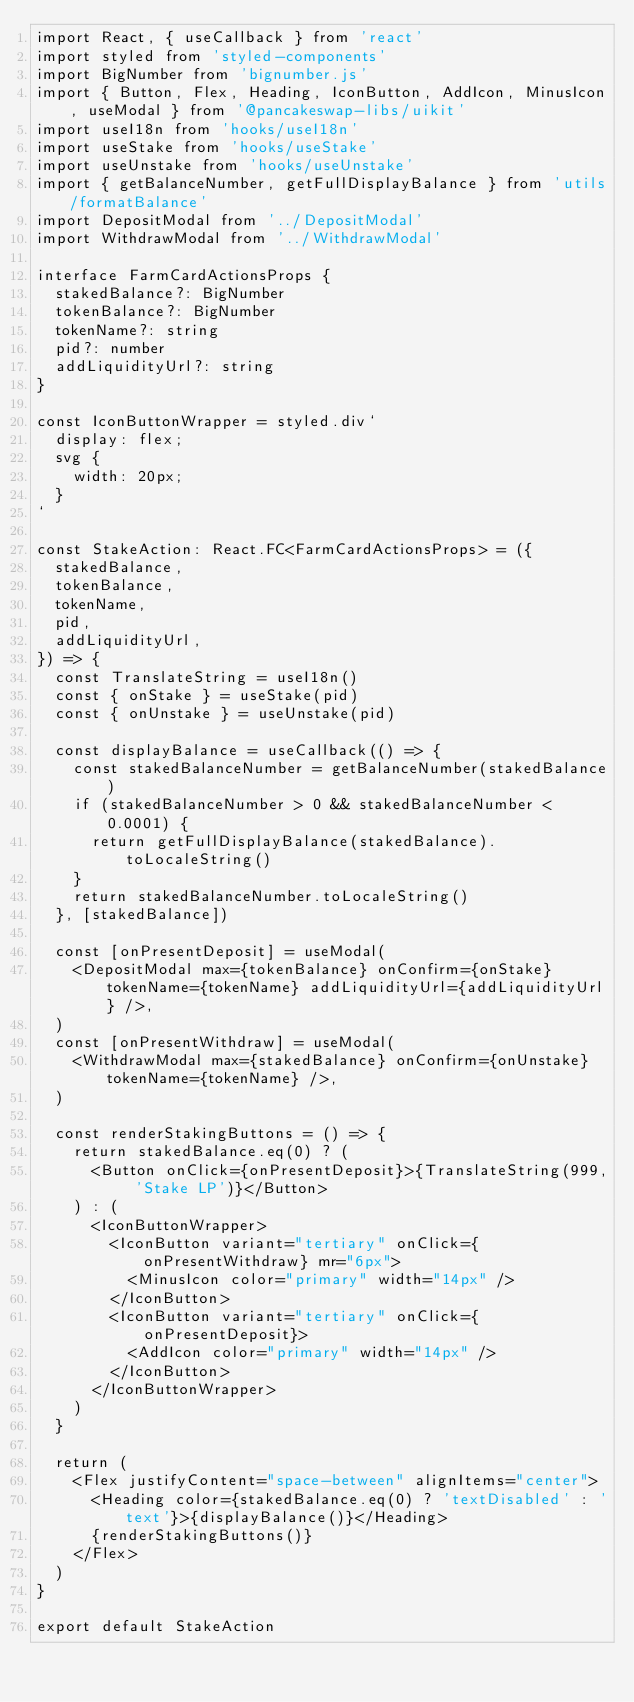<code> <loc_0><loc_0><loc_500><loc_500><_TypeScript_>import React, { useCallback } from 'react'
import styled from 'styled-components'
import BigNumber from 'bignumber.js'
import { Button, Flex, Heading, IconButton, AddIcon, MinusIcon, useModal } from '@pancakeswap-libs/uikit'
import useI18n from 'hooks/useI18n'
import useStake from 'hooks/useStake'
import useUnstake from 'hooks/useUnstake'
import { getBalanceNumber, getFullDisplayBalance } from 'utils/formatBalance'
import DepositModal from '../DepositModal'
import WithdrawModal from '../WithdrawModal'

interface FarmCardActionsProps {
  stakedBalance?: BigNumber
  tokenBalance?: BigNumber
  tokenName?: string
  pid?: number
  addLiquidityUrl?: string
}

const IconButtonWrapper = styled.div`
  display: flex;
  svg {
    width: 20px;
  }
`

const StakeAction: React.FC<FarmCardActionsProps> = ({
  stakedBalance,
  tokenBalance,
  tokenName,
  pid,
  addLiquidityUrl,
}) => {
  const TranslateString = useI18n()
  const { onStake } = useStake(pid)
  const { onUnstake } = useUnstake(pid)

  const displayBalance = useCallback(() => {
    const stakedBalanceNumber = getBalanceNumber(stakedBalance)
    if (stakedBalanceNumber > 0 && stakedBalanceNumber < 0.0001) {
      return getFullDisplayBalance(stakedBalance).toLocaleString()
    }
    return stakedBalanceNumber.toLocaleString()
  }, [stakedBalance])

  const [onPresentDeposit] = useModal(
    <DepositModal max={tokenBalance} onConfirm={onStake} tokenName={tokenName} addLiquidityUrl={addLiquidityUrl} />,
  )
  const [onPresentWithdraw] = useModal(
    <WithdrawModal max={stakedBalance} onConfirm={onUnstake} tokenName={tokenName} />,
  )

  const renderStakingButtons = () => {
    return stakedBalance.eq(0) ? (
      <Button onClick={onPresentDeposit}>{TranslateString(999, 'Stake LP')}</Button>
    ) : (
      <IconButtonWrapper>
        <IconButton variant="tertiary" onClick={onPresentWithdraw} mr="6px">
          <MinusIcon color="primary" width="14px" />
        </IconButton>
        <IconButton variant="tertiary" onClick={onPresentDeposit}>
          <AddIcon color="primary" width="14px" />
        </IconButton>
      </IconButtonWrapper>
    )
  }

  return (
    <Flex justifyContent="space-between" alignItems="center">
      <Heading color={stakedBalance.eq(0) ? 'textDisabled' : 'text'}>{displayBalance()}</Heading>
      {renderStakingButtons()}
    </Flex>
  )
}

export default StakeAction
</code> 